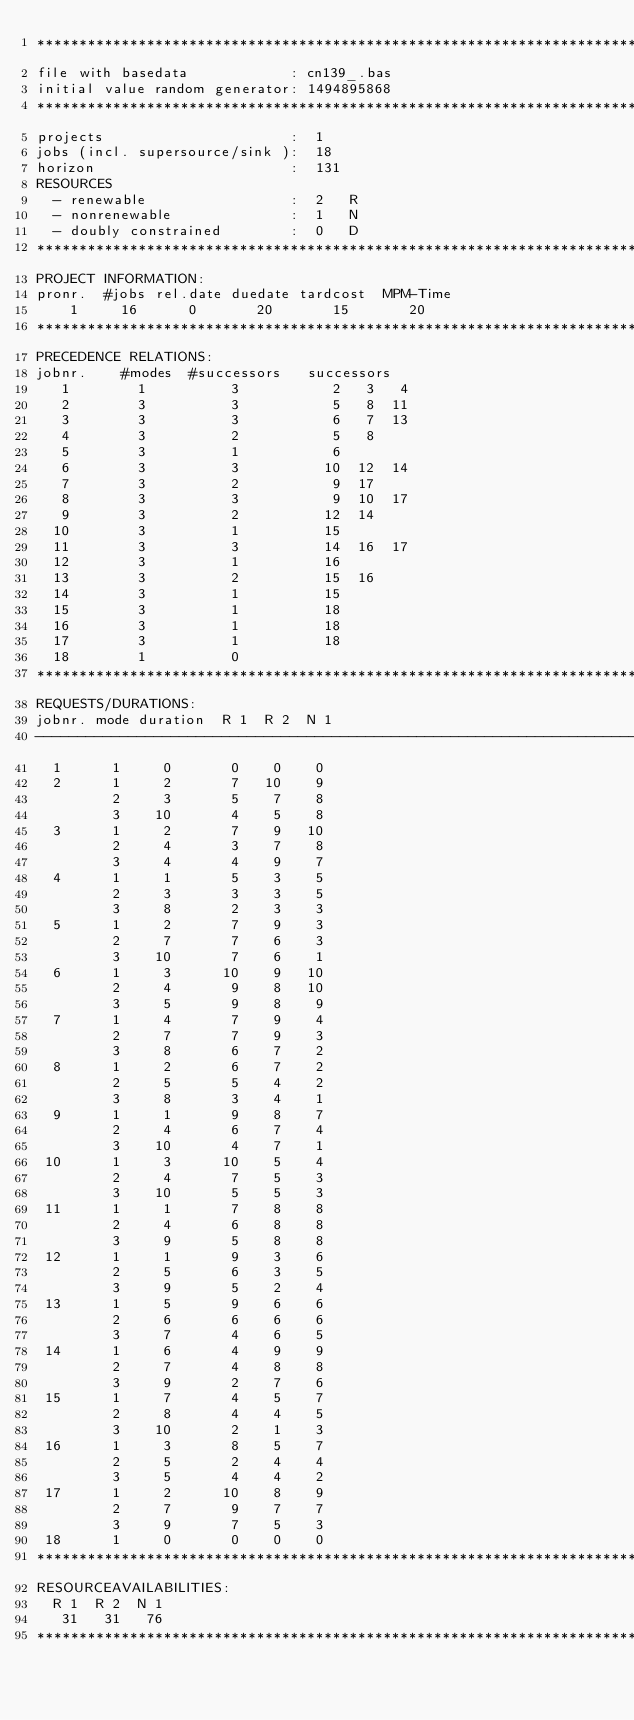Convert code to text. <code><loc_0><loc_0><loc_500><loc_500><_ObjectiveC_>************************************************************************
file with basedata            : cn139_.bas
initial value random generator: 1494895868
************************************************************************
projects                      :  1
jobs (incl. supersource/sink ):  18
horizon                       :  131
RESOURCES
  - renewable                 :  2   R
  - nonrenewable              :  1   N
  - doubly constrained        :  0   D
************************************************************************
PROJECT INFORMATION:
pronr.  #jobs rel.date duedate tardcost  MPM-Time
    1     16      0       20       15       20
************************************************************************
PRECEDENCE RELATIONS:
jobnr.    #modes  #successors   successors
   1        1          3           2   3   4
   2        3          3           5   8  11
   3        3          3           6   7  13
   4        3          2           5   8
   5        3          1           6
   6        3          3          10  12  14
   7        3          2           9  17
   8        3          3           9  10  17
   9        3          2          12  14
  10        3          1          15
  11        3          3          14  16  17
  12        3          1          16
  13        3          2          15  16
  14        3          1          15
  15        3          1          18
  16        3          1          18
  17        3          1          18
  18        1          0        
************************************************************************
REQUESTS/DURATIONS:
jobnr. mode duration  R 1  R 2  N 1
------------------------------------------------------------------------
  1      1     0       0    0    0
  2      1     2       7   10    9
         2     3       5    7    8
         3    10       4    5    8
  3      1     2       7    9   10
         2     4       3    7    8
         3     4       4    9    7
  4      1     1       5    3    5
         2     3       3    3    5
         3     8       2    3    3
  5      1     2       7    9    3
         2     7       7    6    3
         3    10       7    6    1
  6      1     3      10    9   10
         2     4       9    8   10
         3     5       9    8    9
  7      1     4       7    9    4
         2     7       7    9    3
         3     8       6    7    2
  8      1     2       6    7    2
         2     5       5    4    2
         3     8       3    4    1
  9      1     1       9    8    7
         2     4       6    7    4
         3    10       4    7    1
 10      1     3      10    5    4
         2     4       7    5    3
         3    10       5    5    3
 11      1     1       7    8    8
         2     4       6    8    8
         3     9       5    8    8
 12      1     1       9    3    6
         2     5       6    3    5
         3     9       5    2    4
 13      1     5       9    6    6
         2     6       6    6    6
         3     7       4    6    5
 14      1     6       4    9    9
         2     7       4    8    8
         3     9       2    7    6
 15      1     7       4    5    7
         2     8       4    4    5
         3    10       2    1    3
 16      1     3       8    5    7
         2     5       2    4    4
         3     5       4    4    2
 17      1     2      10    8    9
         2     7       9    7    7
         3     9       7    5    3
 18      1     0       0    0    0
************************************************************************
RESOURCEAVAILABILITIES:
  R 1  R 2  N 1
   31   31   76
************************************************************************
</code> 